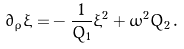<formula> <loc_0><loc_0><loc_500><loc_500>\partial _ { \bar { \rho } } \xi = & - \frac { 1 } { \bar { Q } _ { 1 } } \xi ^ { 2 } + \bar { \omega } ^ { 2 } \bar { Q } _ { 2 } \, .</formula> 